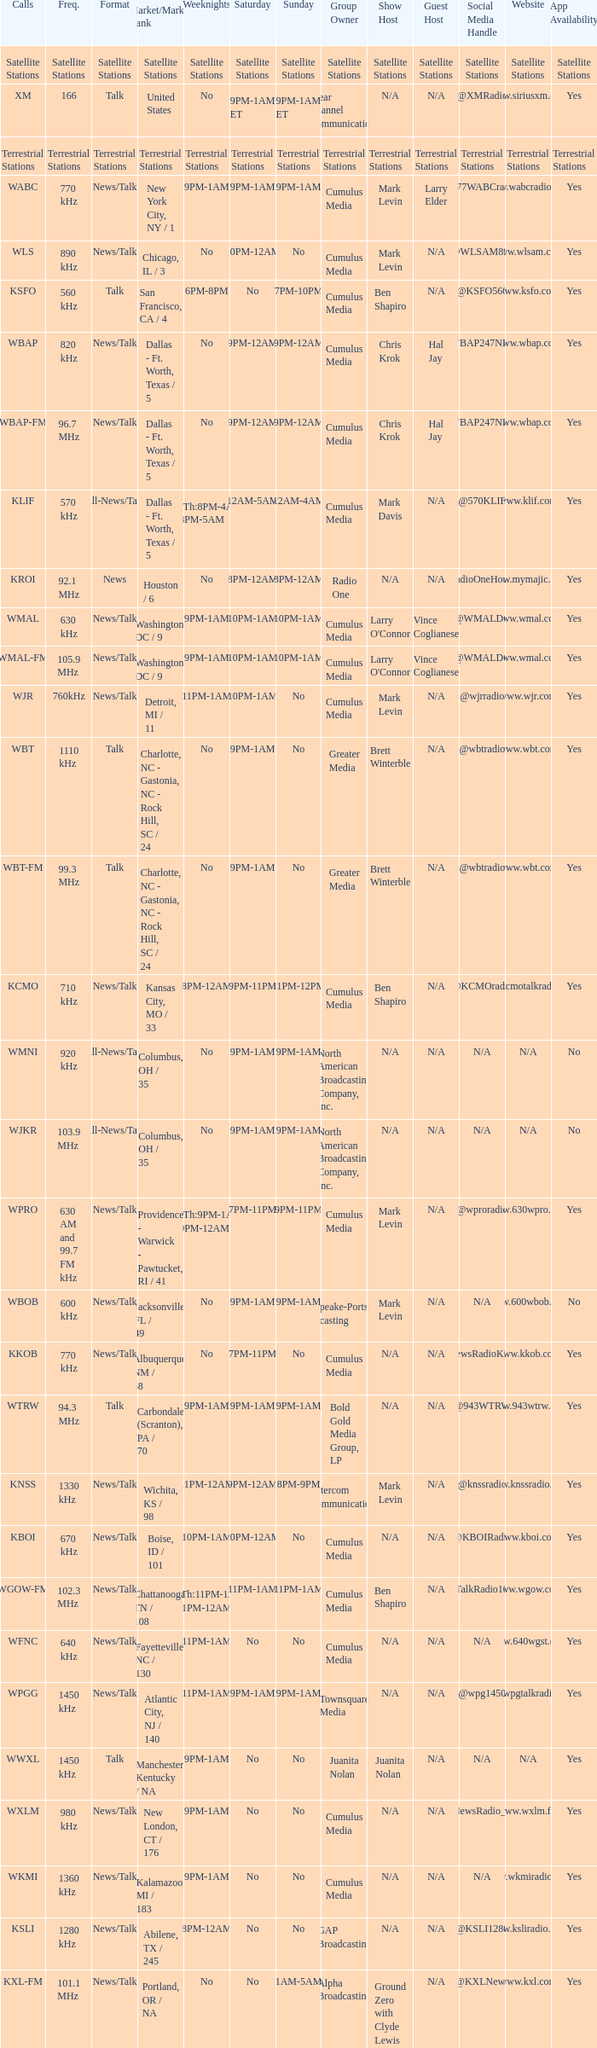What is the market for the 11pm-1am Saturday game? Chattanooga, TN / 108. 